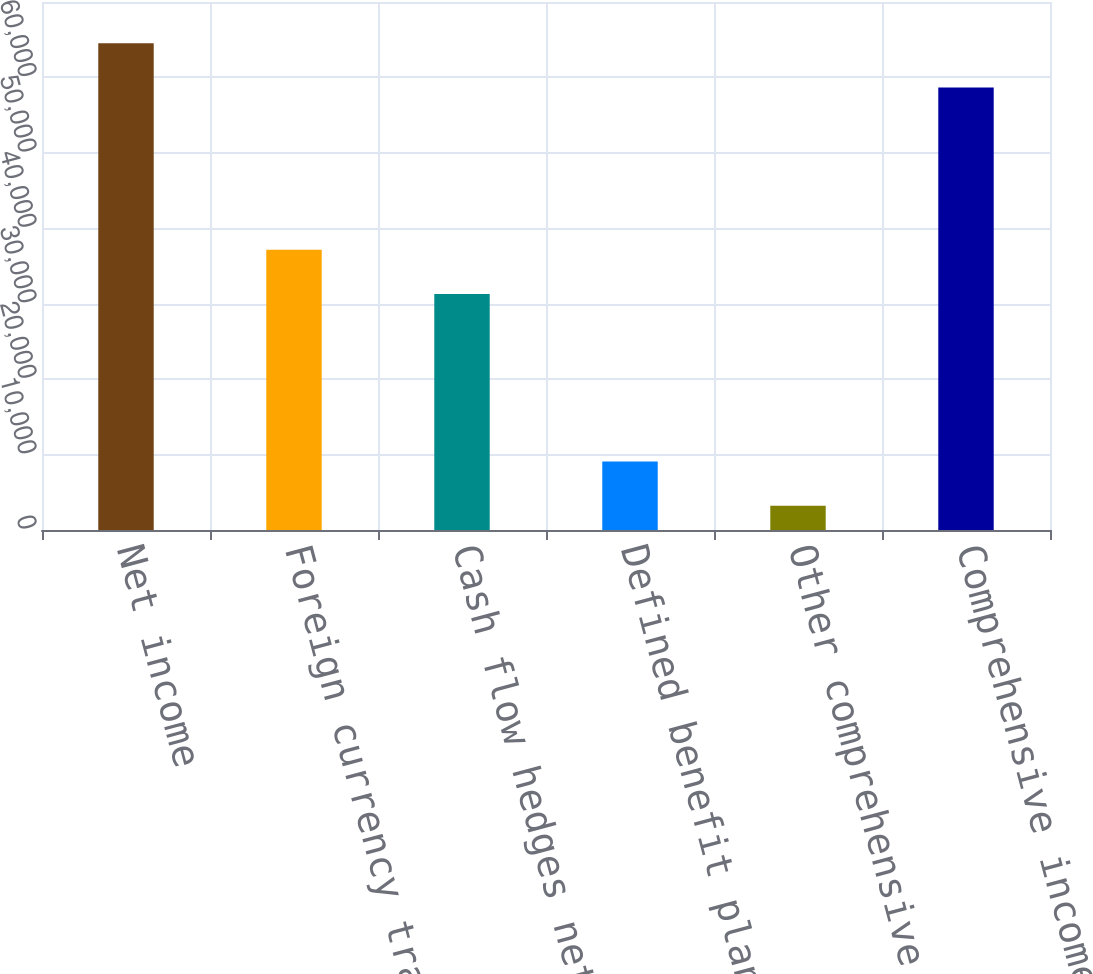Convert chart to OTSL. <chart><loc_0><loc_0><loc_500><loc_500><bar_chart><fcel>Net income<fcel>Foreign currency translation<fcel>Cash flow hedges net of tax<fcel>Defined benefit plans net of<fcel>Other comprehensive loss<fcel>Comprehensive income<nl><fcel>64546.9<fcel>37148.9<fcel>31281<fcel>9082.9<fcel>3215<fcel>58679<nl></chart> 